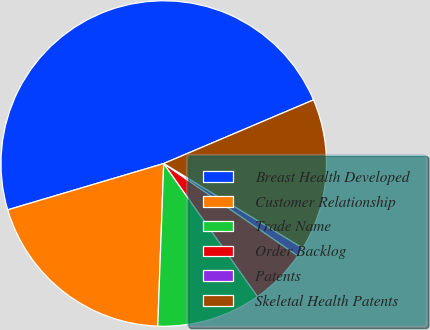Convert chart. <chart><loc_0><loc_0><loc_500><loc_500><pie_chart><fcel>Breast Health Developed<fcel>Customer Relationship<fcel>Trade Name<fcel>Order Backlog<fcel>Patents<fcel>Skeletal Health Patents<nl><fcel>48.2%<fcel>19.82%<fcel>10.36%<fcel>5.63%<fcel>0.9%<fcel>15.09%<nl></chart> 